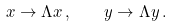Convert formula to latex. <formula><loc_0><loc_0><loc_500><loc_500>x \to \Lambda x \, , \quad y \to \Lambda y \, .</formula> 